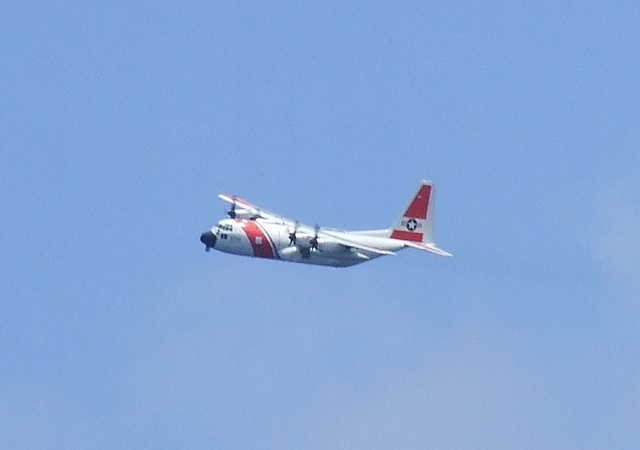Describe the objects in this image and their specific colors. I can see a airplane in darkgray, white, and gray tones in this image. 